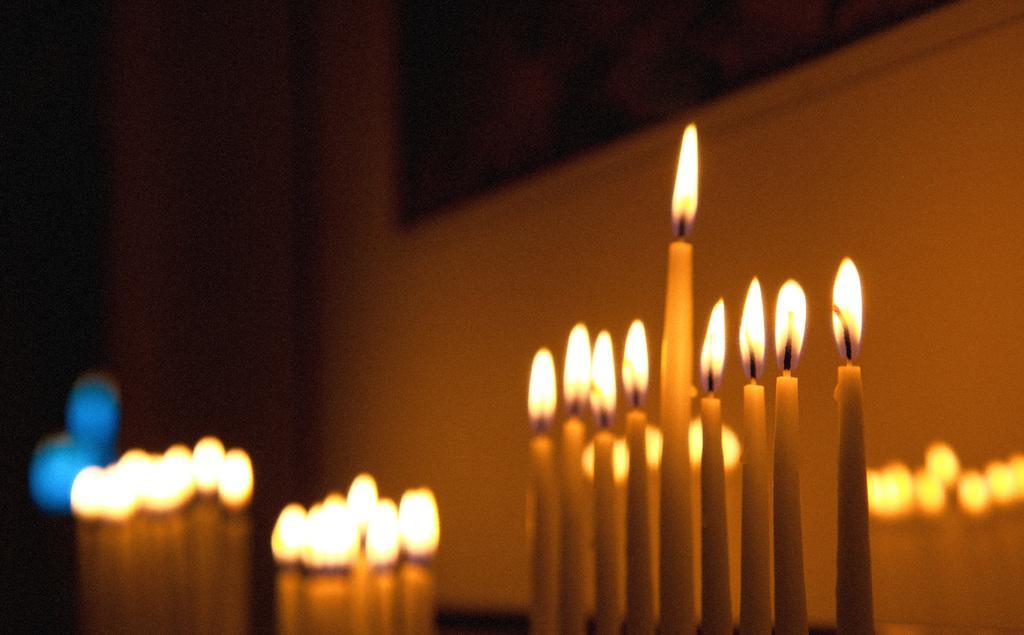Can you describe this image briefly? At the bottom of the picture, we see candles which are lighted. Behind that, we see a white wall on which a photo frame is placed. On the left side, it is black in color. This picture is clicked in the dark. 